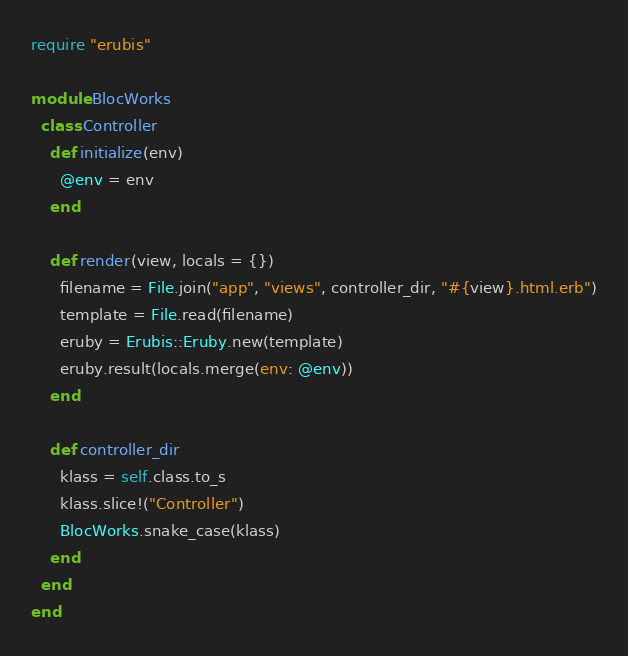<code> <loc_0><loc_0><loc_500><loc_500><_Ruby_>require "erubis"

module BlocWorks
  class Controller
    def initialize(env)
      @env = env
    end

    def render(view, locals = {})
      filename = File.join("app", "views", controller_dir, "#{view}.html.erb")
      template = File.read(filename)
      eruby = Erubis::Eruby.new(template)
      eruby.result(locals.merge(env: @env))
    end

    def controller_dir
      klass = self.class.to_s
      klass.slice!("Controller")
      BlocWorks.snake_case(klass)
    end
  end
end
</code> 